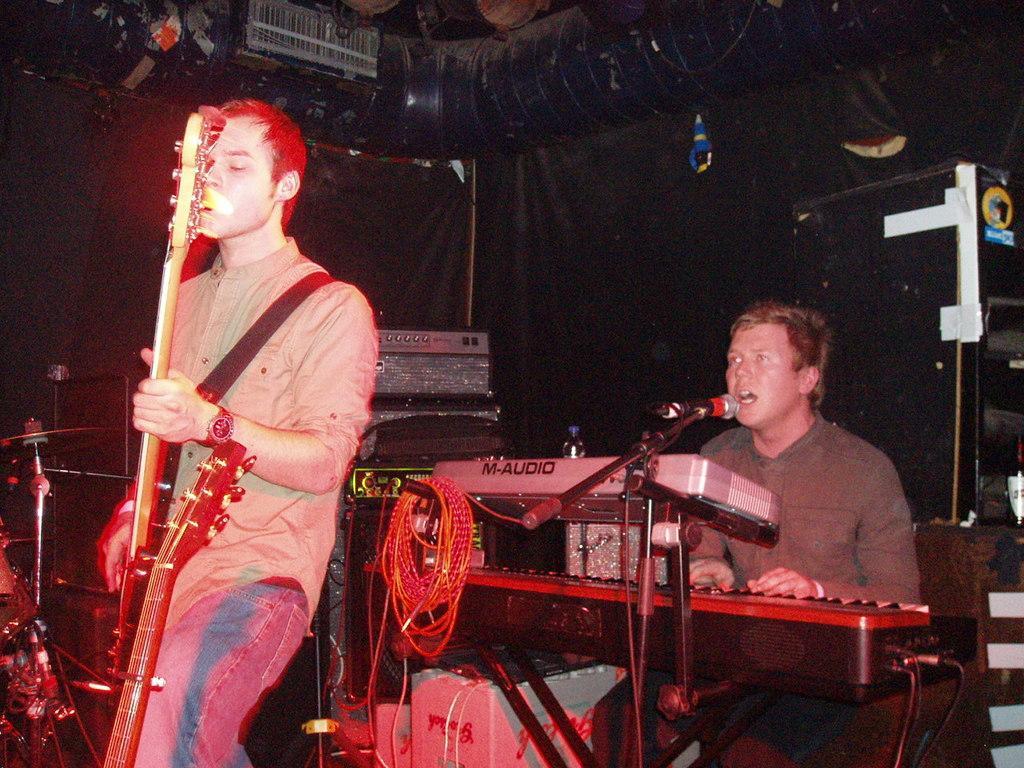Please provide a concise description of this image. In this picture we can see one man sitting and singing in front of a mike and also playing a keyboard. Here we can see one man standing and playing a guitar. 